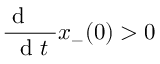Convert formula to latex. <formula><loc_0><loc_0><loc_500><loc_500>\frac { d \, } { d t } x _ { - } ( 0 ) > 0</formula> 